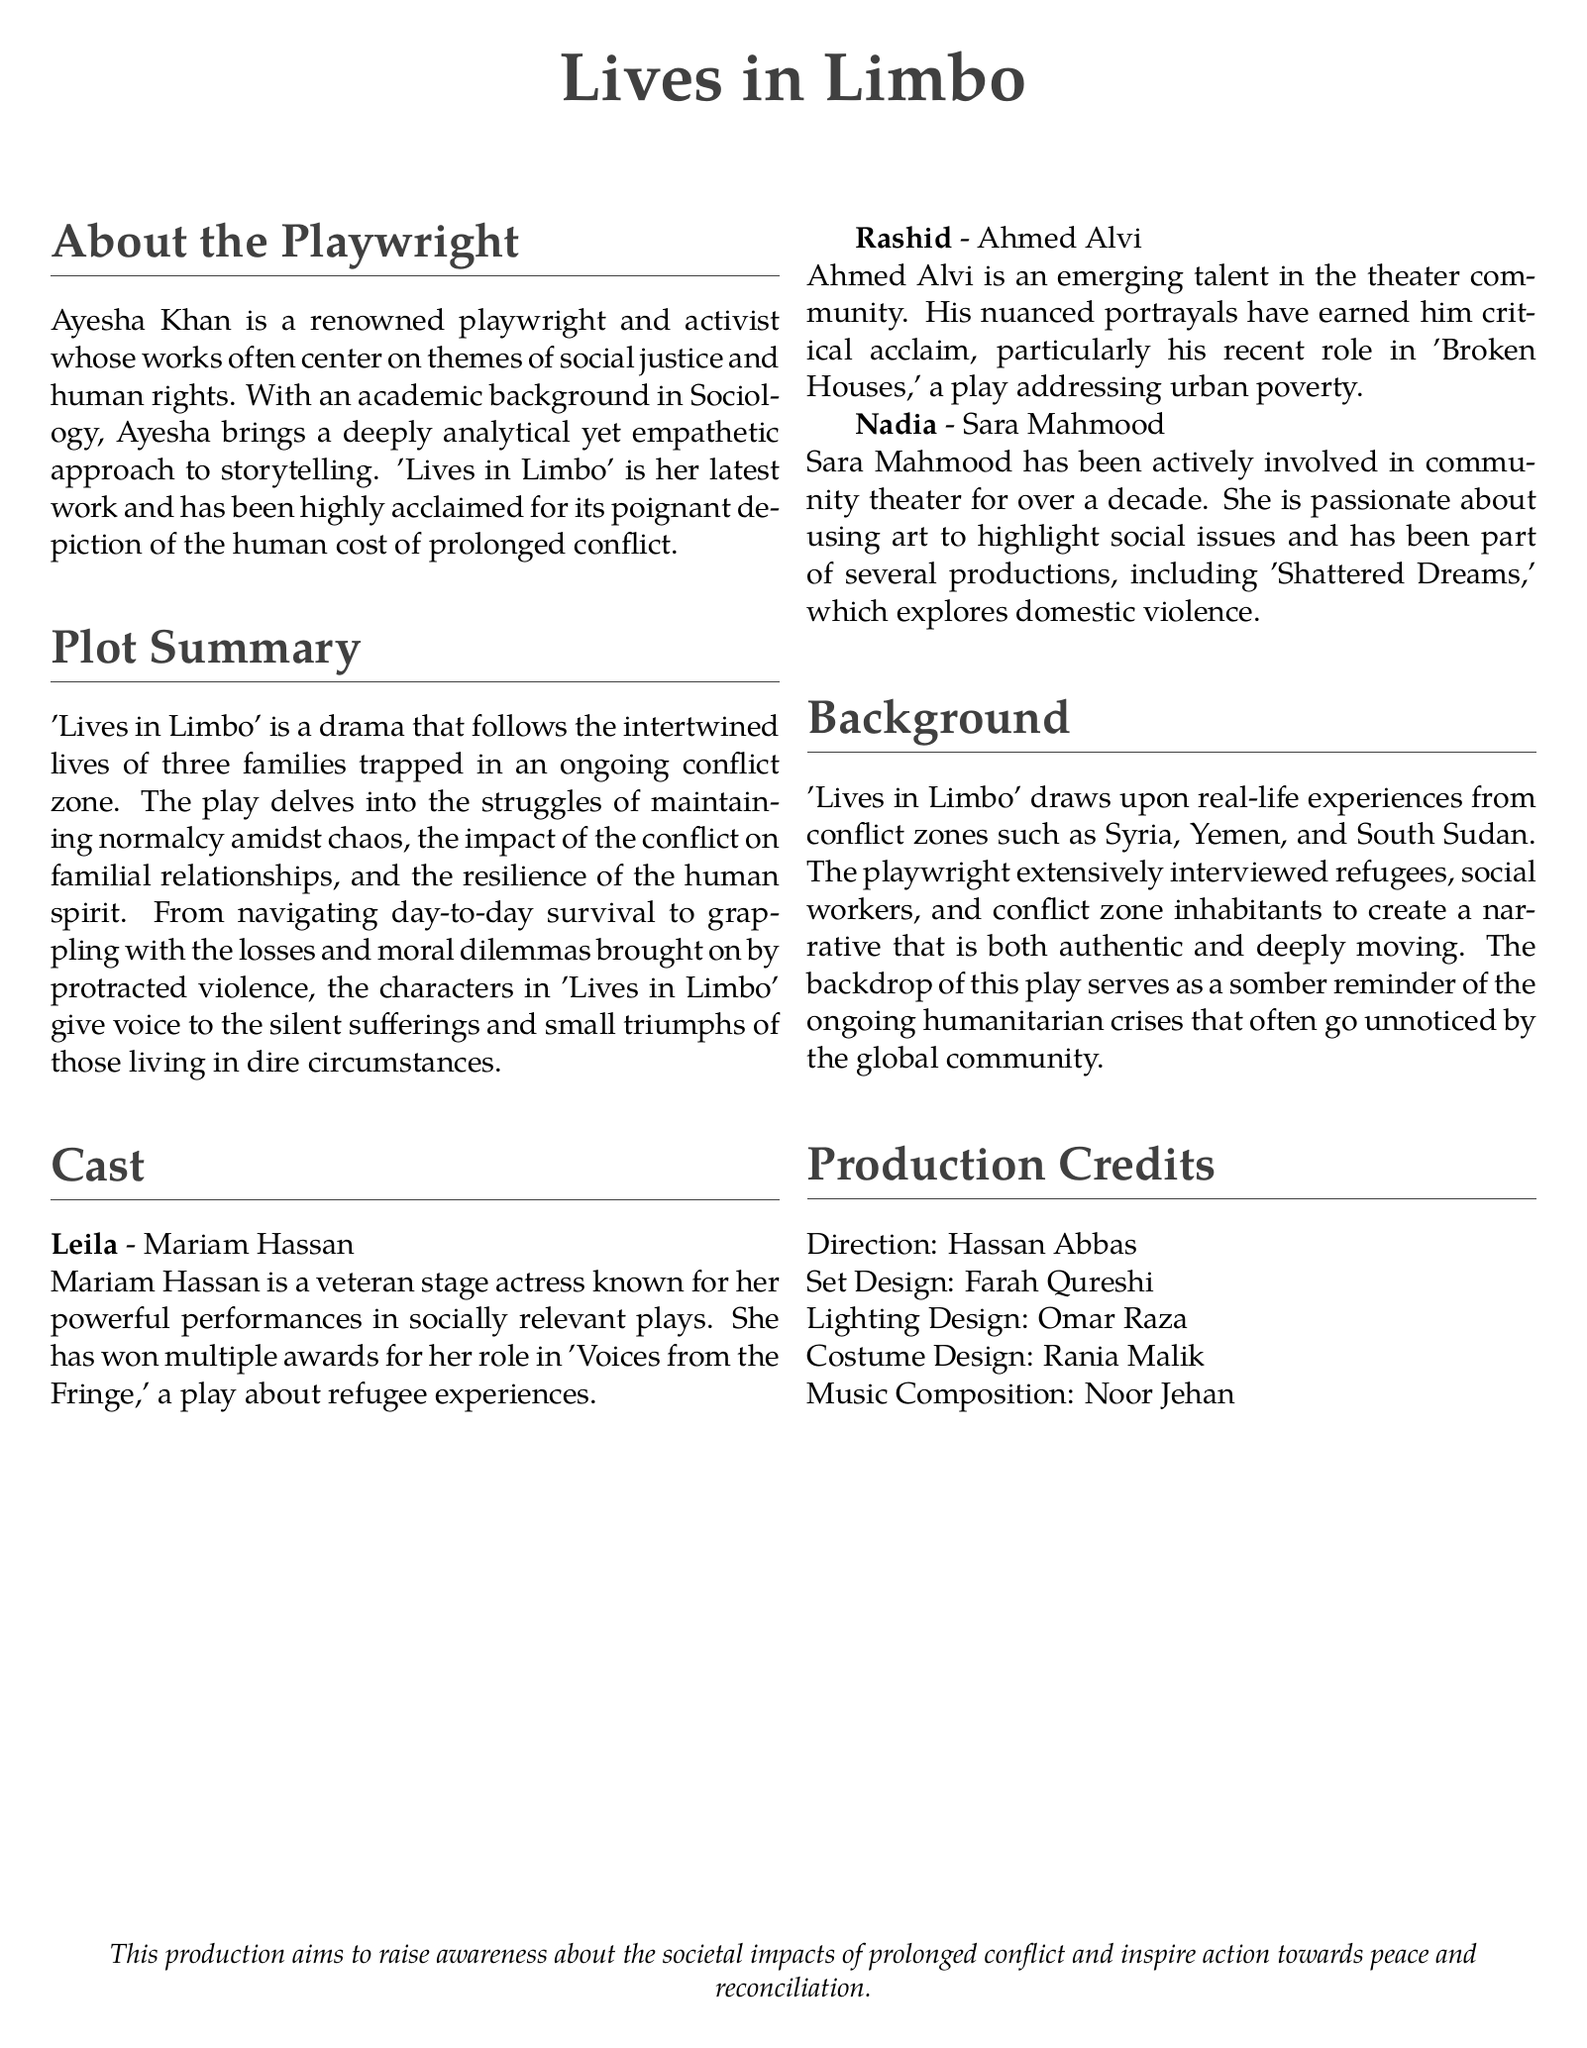What is the name of the playwright? The document states that Ayesha Khan is the playwright of 'Lives in Limbo.'
Answer: Ayesha Khan How many families are followed in the play? The plot summary indicates that three families are central to the narrative of the play.
Answer: three Who plays the character Leila? According to the cast section, Mariam Hassan portrays the character Leila in the production.
Answer: Mariam Hassan What social issue does the play primarily address? The background section mentions the play draws upon real-life experiences from conflict zones and addresses the humanitarian crises resulting from prolonged conflict.
Answer: humanitarian crises What is the profession of Ahmed Alvi? The cast bios specify that Ahmed Alvi is described as an emerging talent in the theater community, highlighting his acting role.
Answer: actor Who is responsible for the set design? The production credits list Farah Qureshi as the set designer for 'Lives in Limbo.'
Answer: Farah Qureshi Which conflict zones inspired 'Lives in Limbo'? The background section provides examples of conflict zones, including Syria, Yemen, and South Sudan.
Answer: Syria, Yemen, South Sudan What is the main theme highlighted in the production's aim? The production aims to raise awareness about the societal impacts of prolonged conflict.
Answer: societal impacts of prolonged conflict 